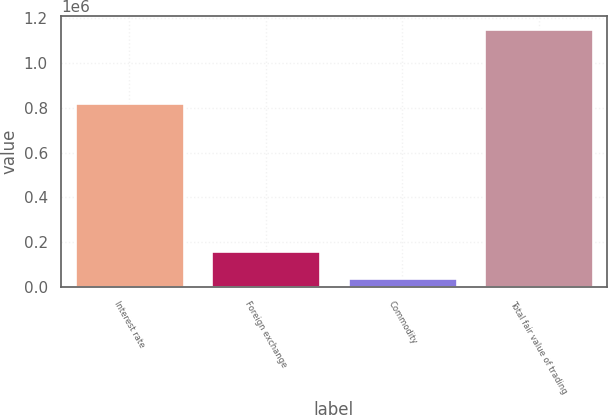Convert chart to OTSL. <chart><loc_0><loc_0><loc_500><loc_500><bar_chart><fcel>Interest rate<fcel>Foreign exchange<fcel>Commodity<fcel>Total fair value of trading<nl><fcel>820811<fcel>158728<fcel>37605<fcel>1.1542e+06<nl></chart> 